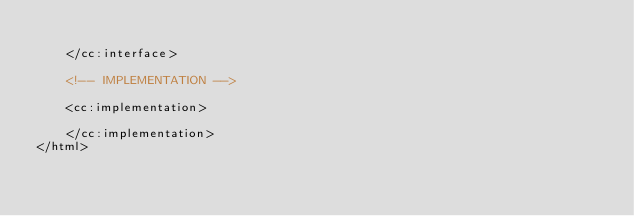Convert code to text. <code><loc_0><loc_0><loc_500><loc_500><_HTML_>
    </cc:interface>

    <!-- IMPLEMENTATION -->

    <cc:implementation>
       
    </cc:implementation>
</html></code> 